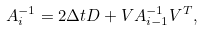Convert formula to latex. <formula><loc_0><loc_0><loc_500><loc_500>A _ { i } ^ { - 1 } = 2 \Delta t D + V A _ { i - 1 } ^ { - 1 } V ^ { T } ,</formula> 